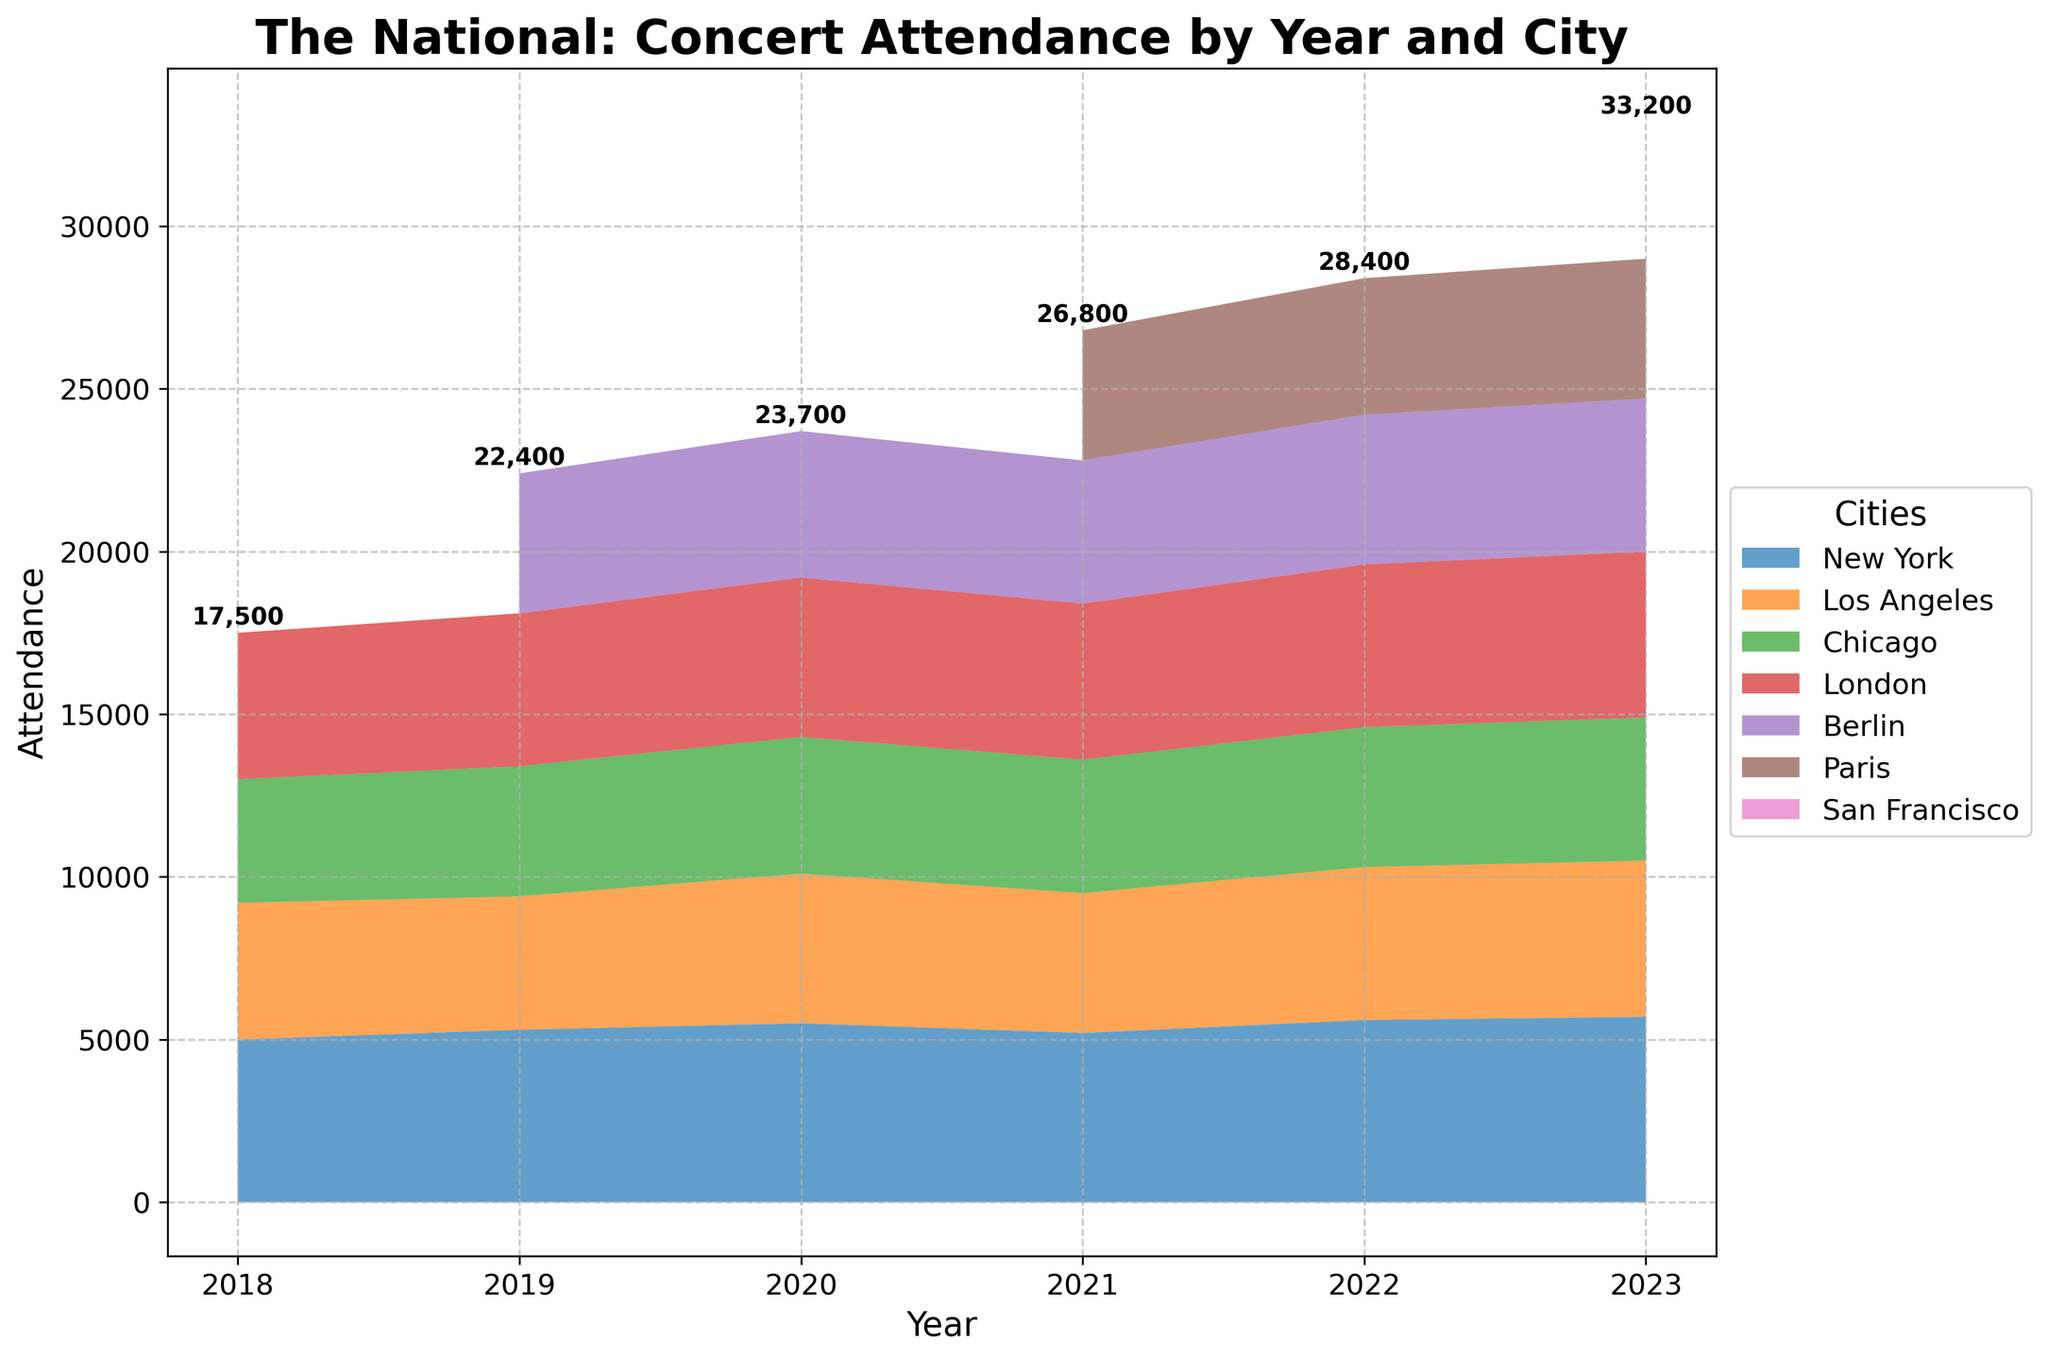What's the title of the figure? The title of the figure is displayed at the top and indicates the main subject being presented in the plot.
Answer: The National: Concert Attendance by Year and City Which city had the highest concert attendance in 2022? To find the highest concert attendance for 2022, look at the values for each city in 2022 and identify the maximum one. London has the highest attendance.
Answer: London Which year had the lowest total concert attendance? Identify the total attendance for each year by summing the stack heights on the area chart for each respective year. The year with the smallest total attendance is 2018.
Answer: 2018 How many cities are shown in the figure for 2020? Look at the data points for the year 2020 and count the number of cities listed in the area chart.
Answer: 5 Compare the attendance in Chicago between 2019 and 2023. Which year had a higher attendance? Locate Chicago's attendance data points for 2019 and 2023 and compare their heights. Since 2023 shows a higher value of 4400 compared to 4000 in 2019.
Answer: 2023 What is the total concert attendance for the year 2023? Sum the attendance numbers for all cities in the year 2023. This is verified by the text on the top of the stacked area.
Answer: 33,300 Which city was added in 2021? Identify new cities by comparing the cities listed in 2020 and 2021. Paris appears in 2021 but not in 2020, indicating it was an addition in 2021.
Answer: Paris Is there a city where the attendance consistently increased every year from 2018 to 2023? Check each city's attendance across the years from 2018 to 2023 and identify if there is a consistent upward trend. New York's attendance increases every year.
Answer: New York How does the attendance in Berlin in 2023 compare to that in 2021? Check Berlin's attendance for years 2021 and 2023 and compare their height values. In 2023 the attendance is 4700, which is higher than in 2021 (4400).
Answer: Berlin in 2023 has higher attendance What was the total concert attendance across all cities in 2020? To find the total concert attendance in 2020, add up the attendance figures for New York, Los Angeles, Chicago, London, and Berlin for that year. The number can be verified from the text on the top of the stack.
Answer: 23,700 